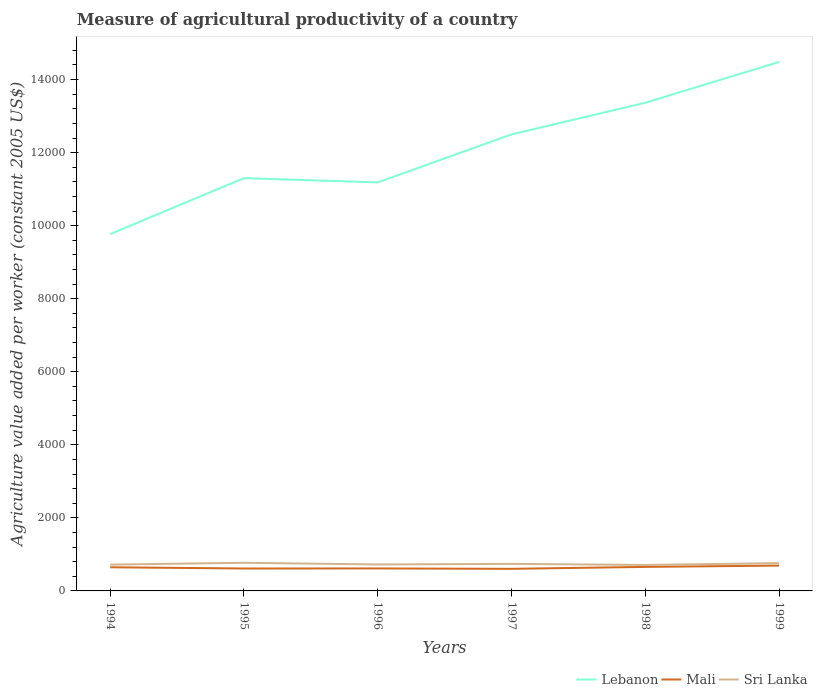How many different coloured lines are there?
Keep it short and to the point. 3. Does the line corresponding to Sri Lanka intersect with the line corresponding to Lebanon?
Provide a short and direct response. No. Is the number of lines equal to the number of legend labels?
Keep it short and to the point. Yes. Across all years, what is the maximum measure of agricultural productivity in Mali?
Provide a succinct answer. 605.02. In which year was the measure of agricultural productivity in Sri Lanka maximum?
Your answer should be very brief. 1998. What is the total measure of agricultural productivity in Lebanon in the graph?
Provide a succinct answer. -3594.89. What is the difference between the highest and the second highest measure of agricultural productivity in Sri Lanka?
Your response must be concise. 59.02. What is the difference between two consecutive major ticks on the Y-axis?
Your answer should be very brief. 2000. Where does the legend appear in the graph?
Make the answer very short. Bottom right. How many legend labels are there?
Your answer should be very brief. 3. How are the legend labels stacked?
Keep it short and to the point. Horizontal. What is the title of the graph?
Your response must be concise. Measure of agricultural productivity of a country. Does "Latin America(developing only)" appear as one of the legend labels in the graph?
Offer a terse response. No. What is the label or title of the X-axis?
Keep it short and to the point. Years. What is the label or title of the Y-axis?
Make the answer very short. Agriculture value added per worker (constant 2005 US$). What is the Agriculture value added per worker (constant 2005 US$) in Lebanon in 1994?
Your response must be concise. 9770.19. What is the Agriculture value added per worker (constant 2005 US$) in Mali in 1994?
Make the answer very short. 647.56. What is the Agriculture value added per worker (constant 2005 US$) of Sri Lanka in 1994?
Your answer should be compact. 719.77. What is the Agriculture value added per worker (constant 2005 US$) of Lebanon in 1995?
Provide a short and direct response. 1.13e+04. What is the Agriculture value added per worker (constant 2005 US$) of Mali in 1995?
Provide a short and direct response. 613.75. What is the Agriculture value added per worker (constant 2005 US$) in Sri Lanka in 1995?
Give a very brief answer. 770.4. What is the Agriculture value added per worker (constant 2005 US$) in Lebanon in 1996?
Your answer should be very brief. 1.12e+04. What is the Agriculture value added per worker (constant 2005 US$) in Mali in 1996?
Offer a terse response. 615.69. What is the Agriculture value added per worker (constant 2005 US$) in Sri Lanka in 1996?
Offer a very short reply. 724.09. What is the Agriculture value added per worker (constant 2005 US$) in Lebanon in 1997?
Provide a short and direct response. 1.25e+04. What is the Agriculture value added per worker (constant 2005 US$) of Mali in 1997?
Your answer should be compact. 605.02. What is the Agriculture value added per worker (constant 2005 US$) of Sri Lanka in 1997?
Offer a terse response. 740.5. What is the Agriculture value added per worker (constant 2005 US$) of Lebanon in 1998?
Keep it short and to the point. 1.34e+04. What is the Agriculture value added per worker (constant 2005 US$) of Mali in 1998?
Give a very brief answer. 657.88. What is the Agriculture value added per worker (constant 2005 US$) in Sri Lanka in 1998?
Your answer should be very brief. 711.38. What is the Agriculture value added per worker (constant 2005 US$) in Lebanon in 1999?
Your answer should be compact. 1.45e+04. What is the Agriculture value added per worker (constant 2005 US$) in Mali in 1999?
Your answer should be compact. 693.81. What is the Agriculture value added per worker (constant 2005 US$) of Sri Lanka in 1999?
Provide a short and direct response. 760.87. Across all years, what is the maximum Agriculture value added per worker (constant 2005 US$) of Lebanon?
Your answer should be compact. 1.45e+04. Across all years, what is the maximum Agriculture value added per worker (constant 2005 US$) in Mali?
Keep it short and to the point. 693.81. Across all years, what is the maximum Agriculture value added per worker (constant 2005 US$) of Sri Lanka?
Your response must be concise. 770.4. Across all years, what is the minimum Agriculture value added per worker (constant 2005 US$) in Lebanon?
Keep it short and to the point. 9770.19. Across all years, what is the minimum Agriculture value added per worker (constant 2005 US$) of Mali?
Offer a terse response. 605.02. Across all years, what is the minimum Agriculture value added per worker (constant 2005 US$) in Sri Lanka?
Your answer should be very brief. 711.38. What is the total Agriculture value added per worker (constant 2005 US$) of Lebanon in the graph?
Offer a very short reply. 7.26e+04. What is the total Agriculture value added per worker (constant 2005 US$) in Mali in the graph?
Offer a terse response. 3833.71. What is the total Agriculture value added per worker (constant 2005 US$) in Sri Lanka in the graph?
Offer a terse response. 4427.01. What is the difference between the Agriculture value added per worker (constant 2005 US$) in Lebanon in 1994 and that in 1995?
Provide a succinct answer. -1531.34. What is the difference between the Agriculture value added per worker (constant 2005 US$) of Mali in 1994 and that in 1995?
Ensure brevity in your answer.  33.81. What is the difference between the Agriculture value added per worker (constant 2005 US$) of Sri Lanka in 1994 and that in 1995?
Give a very brief answer. -50.64. What is the difference between the Agriculture value added per worker (constant 2005 US$) of Lebanon in 1994 and that in 1996?
Offer a very short reply. -1414.87. What is the difference between the Agriculture value added per worker (constant 2005 US$) of Mali in 1994 and that in 1996?
Give a very brief answer. 31.87. What is the difference between the Agriculture value added per worker (constant 2005 US$) of Sri Lanka in 1994 and that in 1996?
Offer a very short reply. -4.33. What is the difference between the Agriculture value added per worker (constant 2005 US$) in Lebanon in 1994 and that in 1997?
Ensure brevity in your answer.  -2728.4. What is the difference between the Agriculture value added per worker (constant 2005 US$) of Mali in 1994 and that in 1997?
Offer a very short reply. 42.54. What is the difference between the Agriculture value added per worker (constant 2005 US$) of Sri Lanka in 1994 and that in 1997?
Give a very brief answer. -20.74. What is the difference between the Agriculture value added per worker (constant 2005 US$) in Lebanon in 1994 and that in 1998?
Your response must be concise. -3594.89. What is the difference between the Agriculture value added per worker (constant 2005 US$) of Mali in 1994 and that in 1998?
Your answer should be compact. -10.32. What is the difference between the Agriculture value added per worker (constant 2005 US$) of Sri Lanka in 1994 and that in 1998?
Offer a very short reply. 8.38. What is the difference between the Agriculture value added per worker (constant 2005 US$) of Lebanon in 1994 and that in 1999?
Offer a terse response. -4713.28. What is the difference between the Agriculture value added per worker (constant 2005 US$) in Mali in 1994 and that in 1999?
Give a very brief answer. -46.25. What is the difference between the Agriculture value added per worker (constant 2005 US$) in Sri Lanka in 1994 and that in 1999?
Offer a terse response. -41.1. What is the difference between the Agriculture value added per worker (constant 2005 US$) in Lebanon in 1995 and that in 1996?
Your response must be concise. 116.47. What is the difference between the Agriculture value added per worker (constant 2005 US$) of Mali in 1995 and that in 1996?
Give a very brief answer. -1.94. What is the difference between the Agriculture value added per worker (constant 2005 US$) of Sri Lanka in 1995 and that in 1996?
Your answer should be compact. 46.31. What is the difference between the Agriculture value added per worker (constant 2005 US$) of Lebanon in 1995 and that in 1997?
Your answer should be compact. -1197.06. What is the difference between the Agriculture value added per worker (constant 2005 US$) of Mali in 1995 and that in 1997?
Offer a terse response. 8.74. What is the difference between the Agriculture value added per worker (constant 2005 US$) in Sri Lanka in 1995 and that in 1997?
Make the answer very short. 29.9. What is the difference between the Agriculture value added per worker (constant 2005 US$) of Lebanon in 1995 and that in 1998?
Provide a short and direct response. -2063.55. What is the difference between the Agriculture value added per worker (constant 2005 US$) in Mali in 1995 and that in 1998?
Ensure brevity in your answer.  -44.13. What is the difference between the Agriculture value added per worker (constant 2005 US$) in Sri Lanka in 1995 and that in 1998?
Make the answer very short. 59.02. What is the difference between the Agriculture value added per worker (constant 2005 US$) of Lebanon in 1995 and that in 1999?
Offer a terse response. -3181.94. What is the difference between the Agriculture value added per worker (constant 2005 US$) in Mali in 1995 and that in 1999?
Provide a succinct answer. -80.05. What is the difference between the Agriculture value added per worker (constant 2005 US$) of Sri Lanka in 1995 and that in 1999?
Provide a succinct answer. 9.54. What is the difference between the Agriculture value added per worker (constant 2005 US$) in Lebanon in 1996 and that in 1997?
Your answer should be very brief. -1313.53. What is the difference between the Agriculture value added per worker (constant 2005 US$) of Mali in 1996 and that in 1997?
Ensure brevity in your answer.  10.67. What is the difference between the Agriculture value added per worker (constant 2005 US$) in Sri Lanka in 1996 and that in 1997?
Keep it short and to the point. -16.41. What is the difference between the Agriculture value added per worker (constant 2005 US$) of Lebanon in 1996 and that in 1998?
Offer a terse response. -2180.02. What is the difference between the Agriculture value added per worker (constant 2005 US$) in Mali in 1996 and that in 1998?
Provide a short and direct response. -42.19. What is the difference between the Agriculture value added per worker (constant 2005 US$) of Sri Lanka in 1996 and that in 1998?
Give a very brief answer. 12.71. What is the difference between the Agriculture value added per worker (constant 2005 US$) in Lebanon in 1996 and that in 1999?
Keep it short and to the point. -3298.41. What is the difference between the Agriculture value added per worker (constant 2005 US$) in Mali in 1996 and that in 1999?
Ensure brevity in your answer.  -78.12. What is the difference between the Agriculture value added per worker (constant 2005 US$) in Sri Lanka in 1996 and that in 1999?
Offer a very short reply. -36.77. What is the difference between the Agriculture value added per worker (constant 2005 US$) of Lebanon in 1997 and that in 1998?
Give a very brief answer. -866.49. What is the difference between the Agriculture value added per worker (constant 2005 US$) of Mali in 1997 and that in 1998?
Your answer should be very brief. -52.86. What is the difference between the Agriculture value added per worker (constant 2005 US$) of Sri Lanka in 1997 and that in 1998?
Provide a succinct answer. 29.12. What is the difference between the Agriculture value added per worker (constant 2005 US$) of Lebanon in 1997 and that in 1999?
Ensure brevity in your answer.  -1984.88. What is the difference between the Agriculture value added per worker (constant 2005 US$) of Mali in 1997 and that in 1999?
Ensure brevity in your answer.  -88.79. What is the difference between the Agriculture value added per worker (constant 2005 US$) of Sri Lanka in 1997 and that in 1999?
Give a very brief answer. -20.37. What is the difference between the Agriculture value added per worker (constant 2005 US$) of Lebanon in 1998 and that in 1999?
Offer a terse response. -1118.39. What is the difference between the Agriculture value added per worker (constant 2005 US$) of Mali in 1998 and that in 1999?
Your response must be concise. -35.93. What is the difference between the Agriculture value added per worker (constant 2005 US$) of Sri Lanka in 1998 and that in 1999?
Offer a terse response. -49.48. What is the difference between the Agriculture value added per worker (constant 2005 US$) of Lebanon in 1994 and the Agriculture value added per worker (constant 2005 US$) of Mali in 1995?
Keep it short and to the point. 9156.44. What is the difference between the Agriculture value added per worker (constant 2005 US$) in Lebanon in 1994 and the Agriculture value added per worker (constant 2005 US$) in Sri Lanka in 1995?
Give a very brief answer. 8999.79. What is the difference between the Agriculture value added per worker (constant 2005 US$) of Mali in 1994 and the Agriculture value added per worker (constant 2005 US$) of Sri Lanka in 1995?
Your response must be concise. -122.84. What is the difference between the Agriculture value added per worker (constant 2005 US$) in Lebanon in 1994 and the Agriculture value added per worker (constant 2005 US$) in Mali in 1996?
Offer a very short reply. 9154.5. What is the difference between the Agriculture value added per worker (constant 2005 US$) in Lebanon in 1994 and the Agriculture value added per worker (constant 2005 US$) in Sri Lanka in 1996?
Provide a short and direct response. 9046.1. What is the difference between the Agriculture value added per worker (constant 2005 US$) in Mali in 1994 and the Agriculture value added per worker (constant 2005 US$) in Sri Lanka in 1996?
Make the answer very short. -76.53. What is the difference between the Agriculture value added per worker (constant 2005 US$) in Lebanon in 1994 and the Agriculture value added per worker (constant 2005 US$) in Mali in 1997?
Your answer should be very brief. 9165.18. What is the difference between the Agriculture value added per worker (constant 2005 US$) of Lebanon in 1994 and the Agriculture value added per worker (constant 2005 US$) of Sri Lanka in 1997?
Offer a very short reply. 9029.69. What is the difference between the Agriculture value added per worker (constant 2005 US$) in Mali in 1994 and the Agriculture value added per worker (constant 2005 US$) in Sri Lanka in 1997?
Ensure brevity in your answer.  -92.94. What is the difference between the Agriculture value added per worker (constant 2005 US$) in Lebanon in 1994 and the Agriculture value added per worker (constant 2005 US$) in Mali in 1998?
Make the answer very short. 9112.31. What is the difference between the Agriculture value added per worker (constant 2005 US$) of Lebanon in 1994 and the Agriculture value added per worker (constant 2005 US$) of Sri Lanka in 1998?
Provide a short and direct response. 9058.81. What is the difference between the Agriculture value added per worker (constant 2005 US$) in Mali in 1994 and the Agriculture value added per worker (constant 2005 US$) in Sri Lanka in 1998?
Offer a terse response. -63.82. What is the difference between the Agriculture value added per worker (constant 2005 US$) in Lebanon in 1994 and the Agriculture value added per worker (constant 2005 US$) in Mali in 1999?
Your answer should be very brief. 9076.39. What is the difference between the Agriculture value added per worker (constant 2005 US$) in Lebanon in 1994 and the Agriculture value added per worker (constant 2005 US$) in Sri Lanka in 1999?
Keep it short and to the point. 9009.33. What is the difference between the Agriculture value added per worker (constant 2005 US$) of Mali in 1994 and the Agriculture value added per worker (constant 2005 US$) of Sri Lanka in 1999?
Keep it short and to the point. -113.31. What is the difference between the Agriculture value added per worker (constant 2005 US$) of Lebanon in 1995 and the Agriculture value added per worker (constant 2005 US$) of Mali in 1996?
Provide a succinct answer. 1.07e+04. What is the difference between the Agriculture value added per worker (constant 2005 US$) of Lebanon in 1995 and the Agriculture value added per worker (constant 2005 US$) of Sri Lanka in 1996?
Offer a terse response. 1.06e+04. What is the difference between the Agriculture value added per worker (constant 2005 US$) in Mali in 1995 and the Agriculture value added per worker (constant 2005 US$) in Sri Lanka in 1996?
Ensure brevity in your answer.  -110.34. What is the difference between the Agriculture value added per worker (constant 2005 US$) of Lebanon in 1995 and the Agriculture value added per worker (constant 2005 US$) of Mali in 1997?
Provide a succinct answer. 1.07e+04. What is the difference between the Agriculture value added per worker (constant 2005 US$) in Lebanon in 1995 and the Agriculture value added per worker (constant 2005 US$) in Sri Lanka in 1997?
Ensure brevity in your answer.  1.06e+04. What is the difference between the Agriculture value added per worker (constant 2005 US$) of Mali in 1995 and the Agriculture value added per worker (constant 2005 US$) of Sri Lanka in 1997?
Provide a short and direct response. -126.75. What is the difference between the Agriculture value added per worker (constant 2005 US$) in Lebanon in 1995 and the Agriculture value added per worker (constant 2005 US$) in Mali in 1998?
Provide a succinct answer. 1.06e+04. What is the difference between the Agriculture value added per worker (constant 2005 US$) in Lebanon in 1995 and the Agriculture value added per worker (constant 2005 US$) in Sri Lanka in 1998?
Give a very brief answer. 1.06e+04. What is the difference between the Agriculture value added per worker (constant 2005 US$) in Mali in 1995 and the Agriculture value added per worker (constant 2005 US$) in Sri Lanka in 1998?
Give a very brief answer. -97.63. What is the difference between the Agriculture value added per worker (constant 2005 US$) in Lebanon in 1995 and the Agriculture value added per worker (constant 2005 US$) in Mali in 1999?
Give a very brief answer. 1.06e+04. What is the difference between the Agriculture value added per worker (constant 2005 US$) in Lebanon in 1995 and the Agriculture value added per worker (constant 2005 US$) in Sri Lanka in 1999?
Give a very brief answer. 1.05e+04. What is the difference between the Agriculture value added per worker (constant 2005 US$) in Mali in 1995 and the Agriculture value added per worker (constant 2005 US$) in Sri Lanka in 1999?
Give a very brief answer. -147.11. What is the difference between the Agriculture value added per worker (constant 2005 US$) in Lebanon in 1996 and the Agriculture value added per worker (constant 2005 US$) in Mali in 1997?
Offer a terse response. 1.06e+04. What is the difference between the Agriculture value added per worker (constant 2005 US$) in Lebanon in 1996 and the Agriculture value added per worker (constant 2005 US$) in Sri Lanka in 1997?
Give a very brief answer. 1.04e+04. What is the difference between the Agriculture value added per worker (constant 2005 US$) of Mali in 1996 and the Agriculture value added per worker (constant 2005 US$) of Sri Lanka in 1997?
Ensure brevity in your answer.  -124.81. What is the difference between the Agriculture value added per worker (constant 2005 US$) in Lebanon in 1996 and the Agriculture value added per worker (constant 2005 US$) in Mali in 1998?
Your answer should be compact. 1.05e+04. What is the difference between the Agriculture value added per worker (constant 2005 US$) in Lebanon in 1996 and the Agriculture value added per worker (constant 2005 US$) in Sri Lanka in 1998?
Give a very brief answer. 1.05e+04. What is the difference between the Agriculture value added per worker (constant 2005 US$) of Mali in 1996 and the Agriculture value added per worker (constant 2005 US$) of Sri Lanka in 1998?
Make the answer very short. -95.69. What is the difference between the Agriculture value added per worker (constant 2005 US$) in Lebanon in 1996 and the Agriculture value added per worker (constant 2005 US$) in Mali in 1999?
Keep it short and to the point. 1.05e+04. What is the difference between the Agriculture value added per worker (constant 2005 US$) in Lebanon in 1996 and the Agriculture value added per worker (constant 2005 US$) in Sri Lanka in 1999?
Keep it short and to the point. 1.04e+04. What is the difference between the Agriculture value added per worker (constant 2005 US$) in Mali in 1996 and the Agriculture value added per worker (constant 2005 US$) in Sri Lanka in 1999?
Offer a very short reply. -145.18. What is the difference between the Agriculture value added per worker (constant 2005 US$) in Lebanon in 1997 and the Agriculture value added per worker (constant 2005 US$) in Mali in 1998?
Your response must be concise. 1.18e+04. What is the difference between the Agriculture value added per worker (constant 2005 US$) of Lebanon in 1997 and the Agriculture value added per worker (constant 2005 US$) of Sri Lanka in 1998?
Make the answer very short. 1.18e+04. What is the difference between the Agriculture value added per worker (constant 2005 US$) in Mali in 1997 and the Agriculture value added per worker (constant 2005 US$) in Sri Lanka in 1998?
Ensure brevity in your answer.  -106.37. What is the difference between the Agriculture value added per worker (constant 2005 US$) in Lebanon in 1997 and the Agriculture value added per worker (constant 2005 US$) in Mali in 1999?
Ensure brevity in your answer.  1.18e+04. What is the difference between the Agriculture value added per worker (constant 2005 US$) in Lebanon in 1997 and the Agriculture value added per worker (constant 2005 US$) in Sri Lanka in 1999?
Keep it short and to the point. 1.17e+04. What is the difference between the Agriculture value added per worker (constant 2005 US$) in Mali in 1997 and the Agriculture value added per worker (constant 2005 US$) in Sri Lanka in 1999?
Your answer should be very brief. -155.85. What is the difference between the Agriculture value added per worker (constant 2005 US$) in Lebanon in 1998 and the Agriculture value added per worker (constant 2005 US$) in Mali in 1999?
Provide a succinct answer. 1.27e+04. What is the difference between the Agriculture value added per worker (constant 2005 US$) in Lebanon in 1998 and the Agriculture value added per worker (constant 2005 US$) in Sri Lanka in 1999?
Your answer should be compact. 1.26e+04. What is the difference between the Agriculture value added per worker (constant 2005 US$) in Mali in 1998 and the Agriculture value added per worker (constant 2005 US$) in Sri Lanka in 1999?
Ensure brevity in your answer.  -102.99. What is the average Agriculture value added per worker (constant 2005 US$) in Lebanon per year?
Ensure brevity in your answer.  1.21e+04. What is the average Agriculture value added per worker (constant 2005 US$) in Mali per year?
Keep it short and to the point. 638.95. What is the average Agriculture value added per worker (constant 2005 US$) of Sri Lanka per year?
Provide a short and direct response. 737.84. In the year 1994, what is the difference between the Agriculture value added per worker (constant 2005 US$) in Lebanon and Agriculture value added per worker (constant 2005 US$) in Mali?
Ensure brevity in your answer.  9122.63. In the year 1994, what is the difference between the Agriculture value added per worker (constant 2005 US$) of Lebanon and Agriculture value added per worker (constant 2005 US$) of Sri Lanka?
Provide a succinct answer. 9050.43. In the year 1994, what is the difference between the Agriculture value added per worker (constant 2005 US$) of Mali and Agriculture value added per worker (constant 2005 US$) of Sri Lanka?
Your answer should be very brief. -72.21. In the year 1995, what is the difference between the Agriculture value added per worker (constant 2005 US$) of Lebanon and Agriculture value added per worker (constant 2005 US$) of Mali?
Make the answer very short. 1.07e+04. In the year 1995, what is the difference between the Agriculture value added per worker (constant 2005 US$) of Lebanon and Agriculture value added per worker (constant 2005 US$) of Sri Lanka?
Offer a very short reply. 1.05e+04. In the year 1995, what is the difference between the Agriculture value added per worker (constant 2005 US$) of Mali and Agriculture value added per worker (constant 2005 US$) of Sri Lanka?
Your answer should be compact. -156.65. In the year 1996, what is the difference between the Agriculture value added per worker (constant 2005 US$) of Lebanon and Agriculture value added per worker (constant 2005 US$) of Mali?
Provide a succinct answer. 1.06e+04. In the year 1996, what is the difference between the Agriculture value added per worker (constant 2005 US$) in Lebanon and Agriculture value added per worker (constant 2005 US$) in Sri Lanka?
Ensure brevity in your answer.  1.05e+04. In the year 1996, what is the difference between the Agriculture value added per worker (constant 2005 US$) of Mali and Agriculture value added per worker (constant 2005 US$) of Sri Lanka?
Ensure brevity in your answer.  -108.4. In the year 1997, what is the difference between the Agriculture value added per worker (constant 2005 US$) of Lebanon and Agriculture value added per worker (constant 2005 US$) of Mali?
Your response must be concise. 1.19e+04. In the year 1997, what is the difference between the Agriculture value added per worker (constant 2005 US$) of Lebanon and Agriculture value added per worker (constant 2005 US$) of Sri Lanka?
Make the answer very short. 1.18e+04. In the year 1997, what is the difference between the Agriculture value added per worker (constant 2005 US$) of Mali and Agriculture value added per worker (constant 2005 US$) of Sri Lanka?
Ensure brevity in your answer.  -135.49. In the year 1998, what is the difference between the Agriculture value added per worker (constant 2005 US$) of Lebanon and Agriculture value added per worker (constant 2005 US$) of Mali?
Ensure brevity in your answer.  1.27e+04. In the year 1998, what is the difference between the Agriculture value added per worker (constant 2005 US$) in Lebanon and Agriculture value added per worker (constant 2005 US$) in Sri Lanka?
Make the answer very short. 1.27e+04. In the year 1998, what is the difference between the Agriculture value added per worker (constant 2005 US$) of Mali and Agriculture value added per worker (constant 2005 US$) of Sri Lanka?
Offer a terse response. -53.5. In the year 1999, what is the difference between the Agriculture value added per worker (constant 2005 US$) of Lebanon and Agriculture value added per worker (constant 2005 US$) of Mali?
Keep it short and to the point. 1.38e+04. In the year 1999, what is the difference between the Agriculture value added per worker (constant 2005 US$) in Lebanon and Agriculture value added per worker (constant 2005 US$) in Sri Lanka?
Make the answer very short. 1.37e+04. In the year 1999, what is the difference between the Agriculture value added per worker (constant 2005 US$) in Mali and Agriculture value added per worker (constant 2005 US$) in Sri Lanka?
Give a very brief answer. -67.06. What is the ratio of the Agriculture value added per worker (constant 2005 US$) in Lebanon in 1994 to that in 1995?
Keep it short and to the point. 0.86. What is the ratio of the Agriculture value added per worker (constant 2005 US$) of Mali in 1994 to that in 1995?
Give a very brief answer. 1.06. What is the ratio of the Agriculture value added per worker (constant 2005 US$) in Sri Lanka in 1994 to that in 1995?
Your answer should be very brief. 0.93. What is the ratio of the Agriculture value added per worker (constant 2005 US$) in Lebanon in 1994 to that in 1996?
Offer a terse response. 0.87. What is the ratio of the Agriculture value added per worker (constant 2005 US$) of Mali in 1994 to that in 1996?
Your response must be concise. 1.05. What is the ratio of the Agriculture value added per worker (constant 2005 US$) of Sri Lanka in 1994 to that in 1996?
Your response must be concise. 0.99. What is the ratio of the Agriculture value added per worker (constant 2005 US$) of Lebanon in 1994 to that in 1997?
Your response must be concise. 0.78. What is the ratio of the Agriculture value added per worker (constant 2005 US$) in Mali in 1994 to that in 1997?
Give a very brief answer. 1.07. What is the ratio of the Agriculture value added per worker (constant 2005 US$) in Lebanon in 1994 to that in 1998?
Provide a short and direct response. 0.73. What is the ratio of the Agriculture value added per worker (constant 2005 US$) of Mali in 1994 to that in 1998?
Ensure brevity in your answer.  0.98. What is the ratio of the Agriculture value added per worker (constant 2005 US$) of Sri Lanka in 1994 to that in 1998?
Ensure brevity in your answer.  1.01. What is the ratio of the Agriculture value added per worker (constant 2005 US$) in Lebanon in 1994 to that in 1999?
Keep it short and to the point. 0.67. What is the ratio of the Agriculture value added per worker (constant 2005 US$) in Sri Lanka in 1994 to that in 1999?
Offer a terse response. 0.95. What is the ratio of the Agriculture value added per worker (constant 2005 US$) in Lebanon in 1995 to that in 1996?
Offer a very short reply. 1.01. What is the ratio of the Agriculture value added per worker (constant 2005 US$) of Sri Lanka in 1995 to that in 1996?
Your answer should be compact. 1.06. What is the ratio of the Agriculture value added per worker (constant 2005 US$) in Lebanon in 1995 to that in 1997?
Your response must be concise. 0.9. What is the ratio of the Agriculture value added per worker (constant 2005 US$) of Mali in 1995 to that in 1997?
Make the answer very short. 1.01. What is the ratio of the Agriculture value added per worker (constant 2005 US$) in Sri Lanka in 1995 to that in 1997?
Provide a succinct answer. 1.04. What is the ratio of the Agriculture value added per worker (constant 2005 US$) of Lebanon in 1995 to that in 1998?
Provide a succinct answer. 0.85. What is the ratio of the Agriculture value added per worker (constant 2005 US$) of Mali in 1995 to that in 1998?
Give a very brief answer. 0.93. What is the ratio of the Agriculture value added per worker (constant 2005 US$) in Sri Lanka in 1995 to that in 1998?
Give a very brief answer. 1.08. What is the ratio of the Agriculture value added per worker (constant 2005 US$) in Lebanon in 1995 to that in 1999?
Your response must be concise. 0.78. What is the ratio of the Agriculture value added per worker (constant 2005 US$) in Mali in 1995 to that in 1999?
Make the answer very short. 0.88. What is the ratio of the Agriculture value added per worker (constant 2005 US$) of Sri Lanka in 1995 to that in 1999?
Give a very brief answer. 1.01. What is the ratio of the Agriculture value added per worker (constant 2005 US$) of Lebanon in 1996 to that in 1997?
Offer a terse response. 0.89. What is the ratio of the Agriculture value added per worker (constant 2005 US$) of Mali in 1996 to that in 1997?
Your answer should be compact. 1.02. What is the ratio of the Agriculture value added per worker (constant 2005 US$) in Sri Lanka in 1996 to that in 1997?
Your answer should be very brief. 0.98. What is the ratio of the Agriculture value added per worker (constant 2005 US$) of Lebanon in 1996 to that in 1998?
Your answer should be very brief. 0.84. What is the ratio of the Agriculture value added per worker (constant 2005 US$) in Mali in 1996 to that in 1998?
Provide a succinct answer. 0.94. What is the ratio of the Agriculture value added per worker (constant 2005 US$) of Sri Lanka in 1996 to that in 1998?
Your answer should be very brief. 1.02. What is the ratio of the Agriculture value added per worker (constant 2005 US$) in Lebanon in 1996 to that in 1999?
Make the answer very short. 0.77. What is the ratio of the Agriculture value added per worker (constant 2005 US$) of Mali in 1996 to that in 1999?
Provide a succinct answer. 0.89. What is the ratio of the Agriculture value added per worker (constant 2005 US$) in Sri Lanka in 1996 to that in 1999?
Your response must be concise. 0.95. What is the ratio of the Agriculture value added per worker (constant 2005 US$) of Lebanon in 1997 to that in 1998?
Provide a short and direct response. 0.94. What is the ratio of the Agriculture value added per worker (constant 2005 US$) in Mali in 1997 to that in 1998?
Offer a terse response. 0.92. What is the ratio of the Agriculture value added per worker (constant 2005 US$) of Sri Lanka in 1997 to that in 1998?
Offer a very short reply. 1.04. What is the ratio of the Agriculture value added per worker (constant 2005 US$) of Lebanon in 1997 to that in 1999?
Your answer should be compact. 0.86. What is the ratio of the Agriculture value added per worker (constant 2005 US$) in Mali in 1997 to that in 1999?
Your response must be concise. 0.87. What is the ratio of the Agriculture value added per worker (constant 2005 US$) of Sri Lanka in 1997 to that in 1999?
Provide a succinct answer. 0.97. What is the ratio of the Agriculture value added per worker (constant 2005 US$) in Lebanon in 1998 to that in 1999?
Ensure brevity in your answer.  0.92. What is the ratio of the Agriculture value added per worker (constant 2005 US$) of Mali in 1998 to that in 1999?
Your response must be concise. 0.95. What is the ratio of the Agriculture value added per worker (constant 2005 US$) of Sri Lanka in 1998 to that in 1999?
Make the answer very short. 0.94. What is the difference between the highest and the second highest Agriculture value added per worker (constant 2005 US$) in Lebanon?
Keep it short and to the point. 1118.39. What is the difference between the highest and the second highest Agriculture value added per worker (constant 2005 US$) of Mali?
Your answer should be compact. 35.93. What is the difference between the highest and the second highest Agriculture value added per worker (constant 2005 US$) in Sri Lanka?
Provide a short and direct response. 9.54. What is the difference between the highest and the lowest Agriculture value added per worker (constant 2005 US$) in Lebanon?
Your response must be concise. 4713.28. What is the difference between the highest and the lowest Agriculture value added per worker (constant 2005 US$) in Mali?
Ensure brevity in your answer.  88.79. What is the difference between the highest and the lowest Agriculture value added per worker (constant 2005 US$) in Sri Lanka?
Keep it short and to the point. 59.02. 